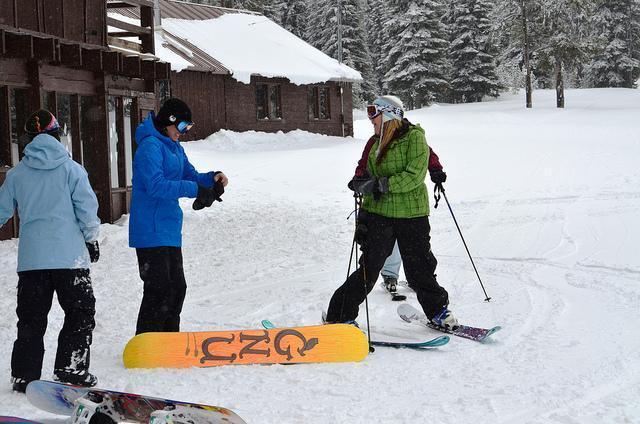How many people are wearing goggles?
Give a very brief answer. 2. How many skiers don't have poles?
Give a very brief answer. 2. How many snowboards are there?
Give a very brief answer. 2. How many people are there?
Give a very brief answer. 3. 